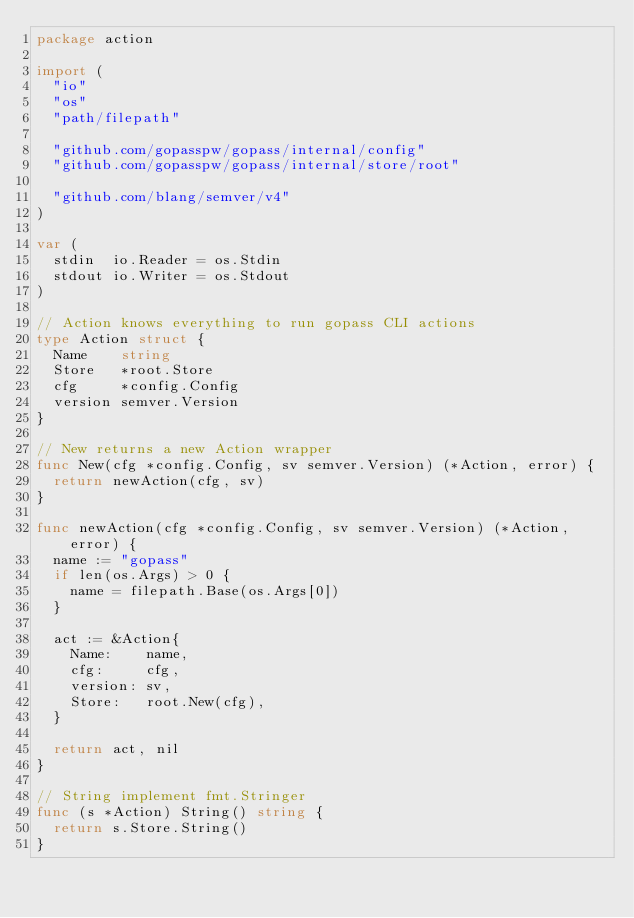<code> <loc_0><loc_0><loc_500><loc_500><_Go_>package action

import (
	"io"
	"os"
	"path/filepath"

	"github.com/gopasspw/gopass/internal/config"
	"github.com/gopasspw/gopass/internal/store/root"

	"github.com/blang/semver/v4"
)

var (
	stdin  io.Reader = os.Stdin
	stdout io.Writer = os.Stdout
)

// Action knows everything to run gopass CLI actions
type Action struct {
	Name    string
	Store   *root.Store
	cfg     *config.Config
	version semver.Version
}

// New returns a new Action wrapper
func New(cfg *config.Config, sv semver.Version) (*Action, error) {
	return newAction(cfg, sv)
}

func newAction(cfg *config.Config, sv semver.Version) (*Action, error) {
	name := "gopass"
	if len(os.Args) > 0 {
		name = filepath.Base(os.Args[0])
	}

	act := &Action{
		Name:    name,
		cfg:     cfg,
		version: sv,
		Store:   root.New(cfg),
	}

	return act, nil
}

// String implement fmt.Stringer
func (s *Action) String() string {
	return s.Store.String()
}
</code> 